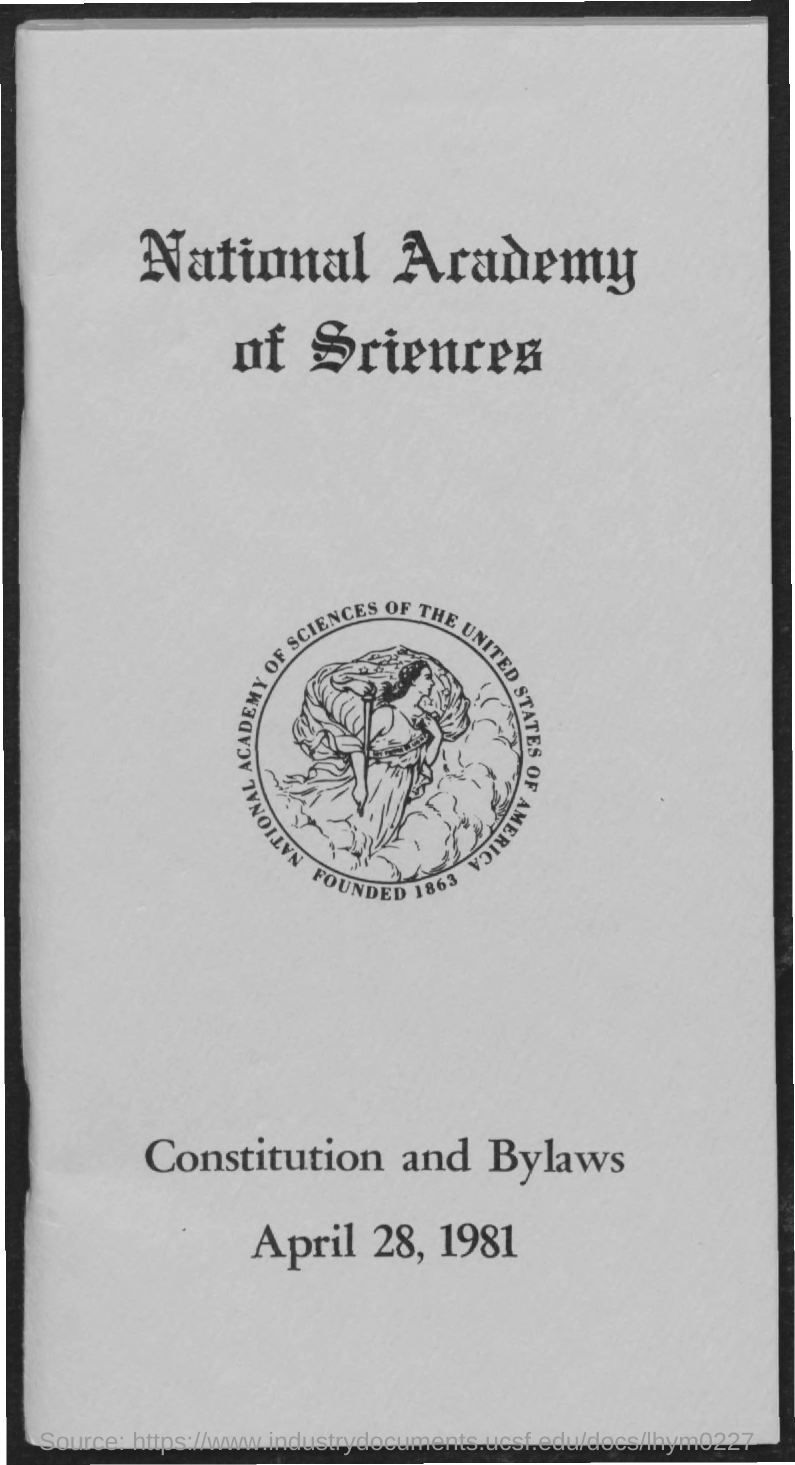What is the date mentioned in the given page ?
Keep it short and to the point. April 28, 1981. 